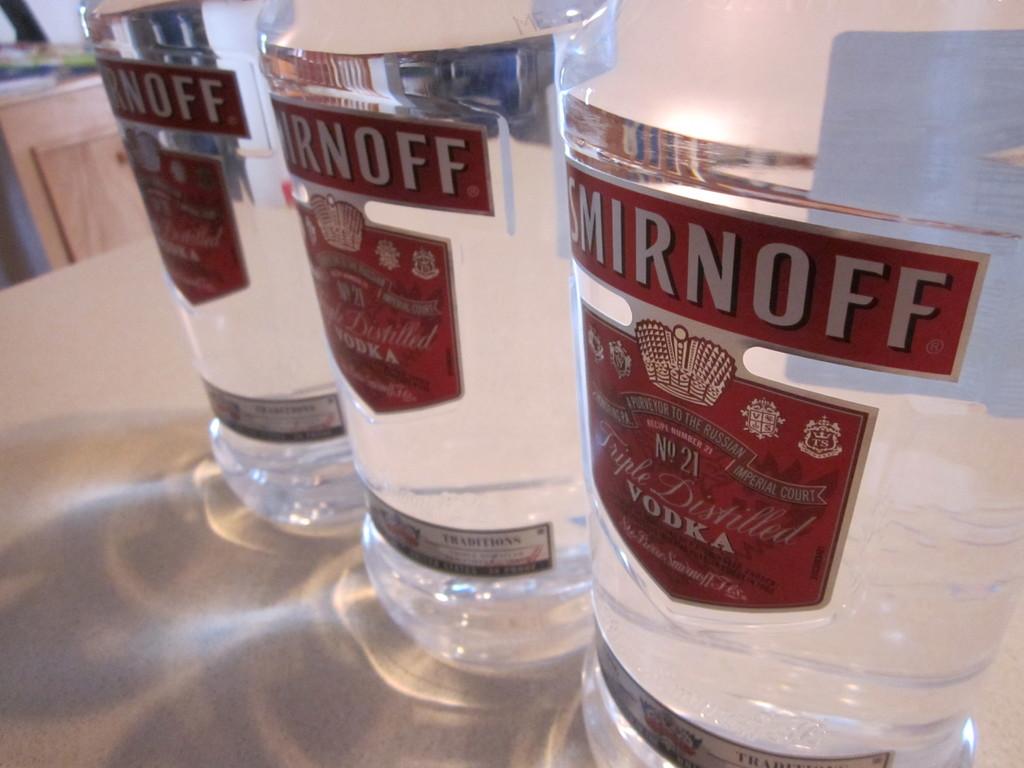What is this brand of vodka?
Ensure brevity in your answer.  Smirnoff. What recepie number is this made from?
Ensure brevity in your answer.  21. 